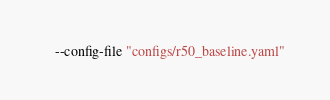Convert code to text. <code><loc_0><loc_0><loc_500><loc_500><_Bash_>	--config-file "configs/r50_baseline.yaml" 
</code> 